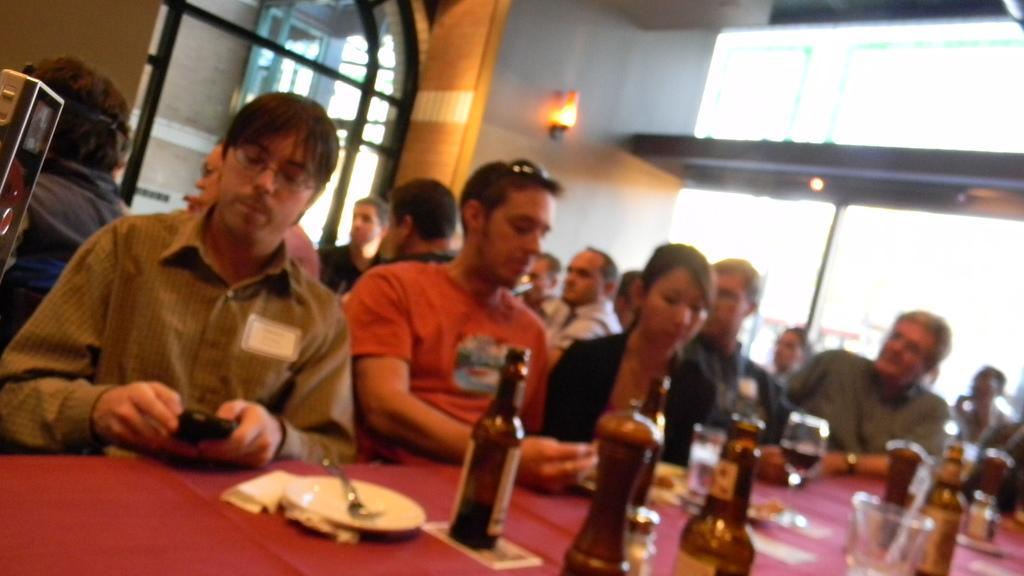Please provide a concise description of this image. Persons are sitting on a chair. In-front of them there is a table, on this table there are bottles, glasses and plates. On top there are lights. This is window. 